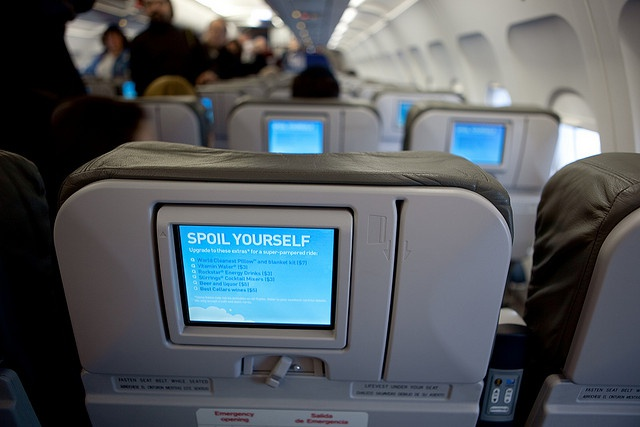Describe the objects in this image and their specific colors. I can see chair in black and gray tones, tv in black and lightblue tones, chair in black and gray tones, chair in black, gray, and darkblue tones, and chair in black, darkgray, gray, and lightblue tones in this image. 